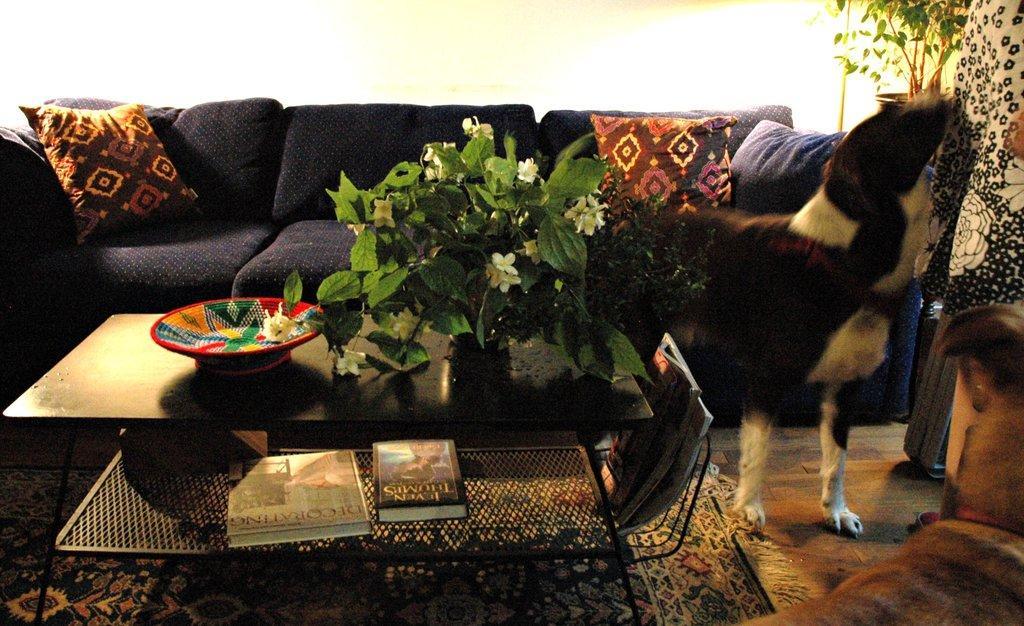Can you describe this image briefly? In this picture there is a flower pot and a plant, colorful bowl, books on the table. There is a dog. There is another flower pot at the background. There is a sofa, pillow carpet and black and white cloth. 